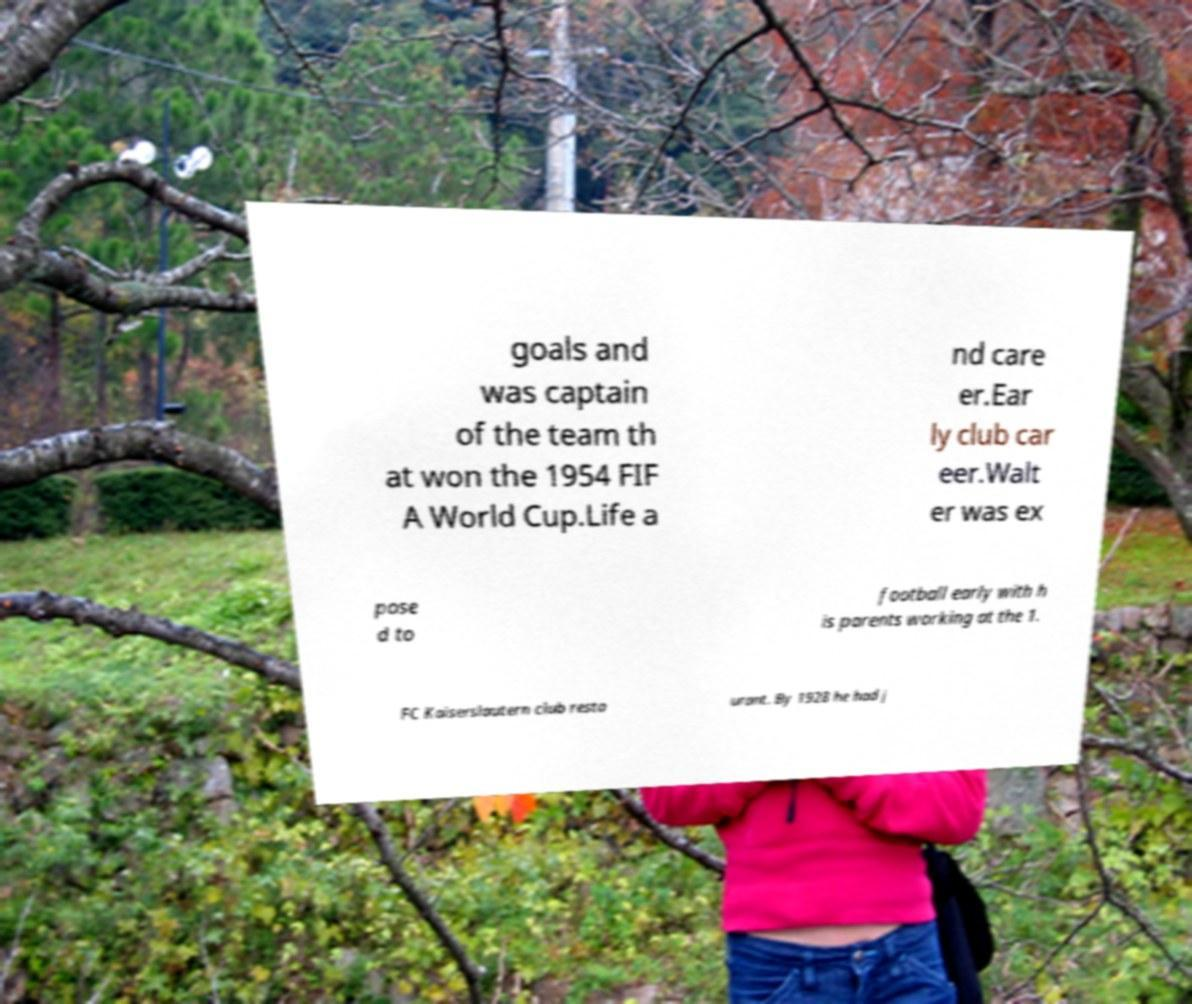Could you assist in decoding the text presented in this image and type it out clearly? goals and was captain of the team th at won the 1954 FIF A World Cup.Life a nd care er.Ear ly club car eer.Walt er was ex pose d to football early with h is parents working at the 1. FC Kaiserslautern club resta urant. By 1928 he had j 